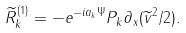Convert formula to latex. <formula><loc_0><loc_0><loc_500><loc_500>\widetilde { R } _ { k } ^ { ( 1 ) } = - e ^ { - i a _ { k } \Psi } P _ { k } \partial _ { x } ( \widetilde { v } ^ { 2 } / 2 ) .</formula> 